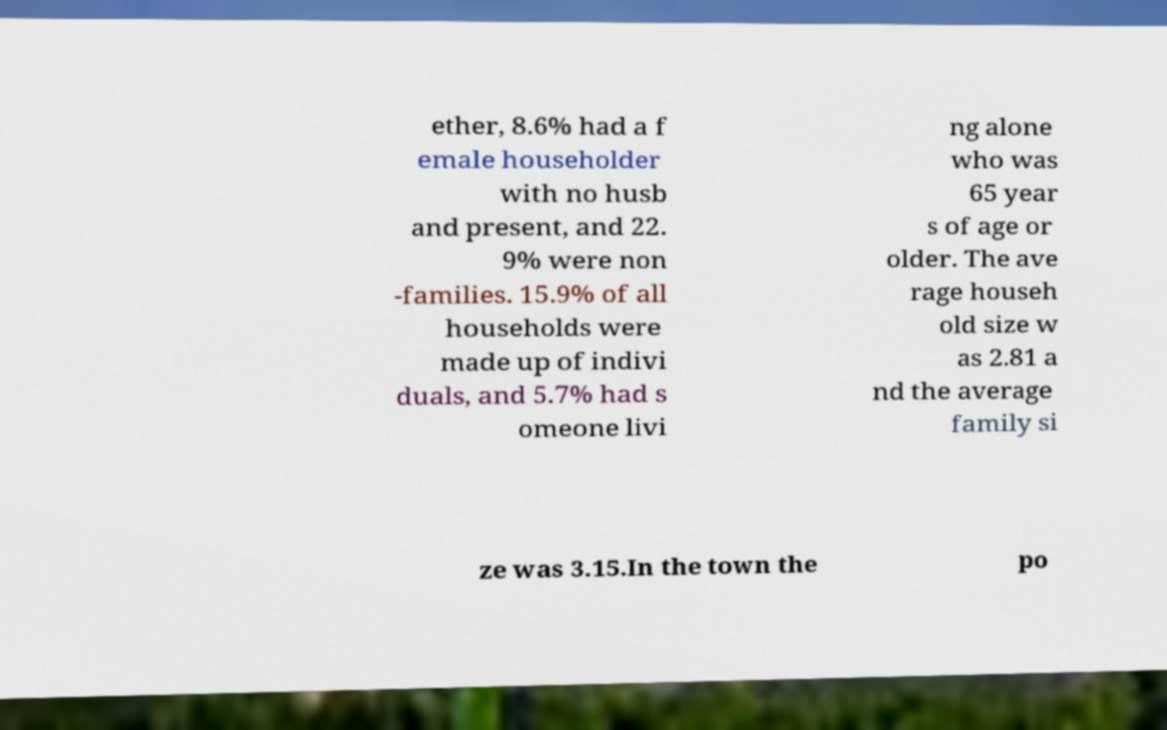Please read and relay the text visible in this image. What does it say? ether, 8.6% had a f emale householder with no husb and present, and 22. 9% were non -families. 15.9% of all households were made up of indivi duals, and 5.7% had s omeone livi ng alone who was 65 year s of age or older. The ave rage househ old size w as 2.81 a nd the average family si ze was 3.15.In the town the po 